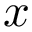<formula> <loc_0><loc_0><loc_500><loc_500>x</formula> 